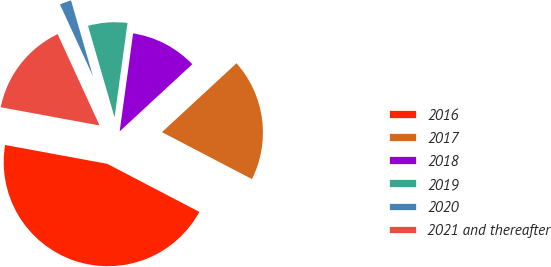Convert chart to OTSL. <chart><loc_0><loc_0><loc_500><loc_500><pie_chart><fcel>2016<fcel>2017<fcel>2018<fcel>2019<fcel>2020<fcel>2021 and thereafter<nl><fcel>45.25%<fcel>19.53%<fcel>10.95%<fcel>6.66%<fcel>2.37%<fcel>15.24%<nl></chart> 